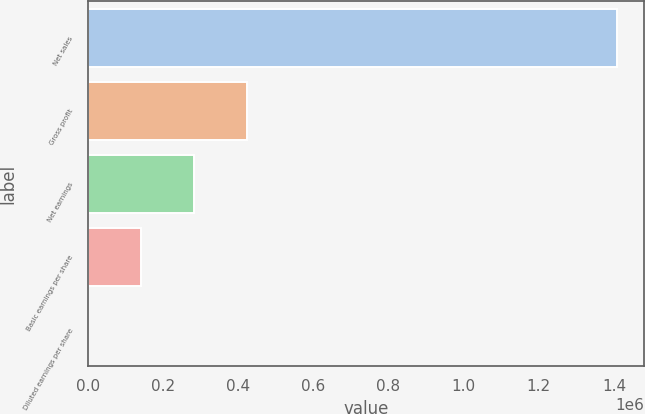Convert chart to OTSL. <chart><loc_0><loc_0><loc_500><loc_500><bar_chart><fcel>Net sales<fcel>Gross profit<fcel>Net earnings<fcel>Basic earnings per share<fcel>Diluted earnings per share<nl><fcel>1.40904e+06<fcel>422711<fcel>281807<fcel>140904<fcel>0.58<nl></chart> 